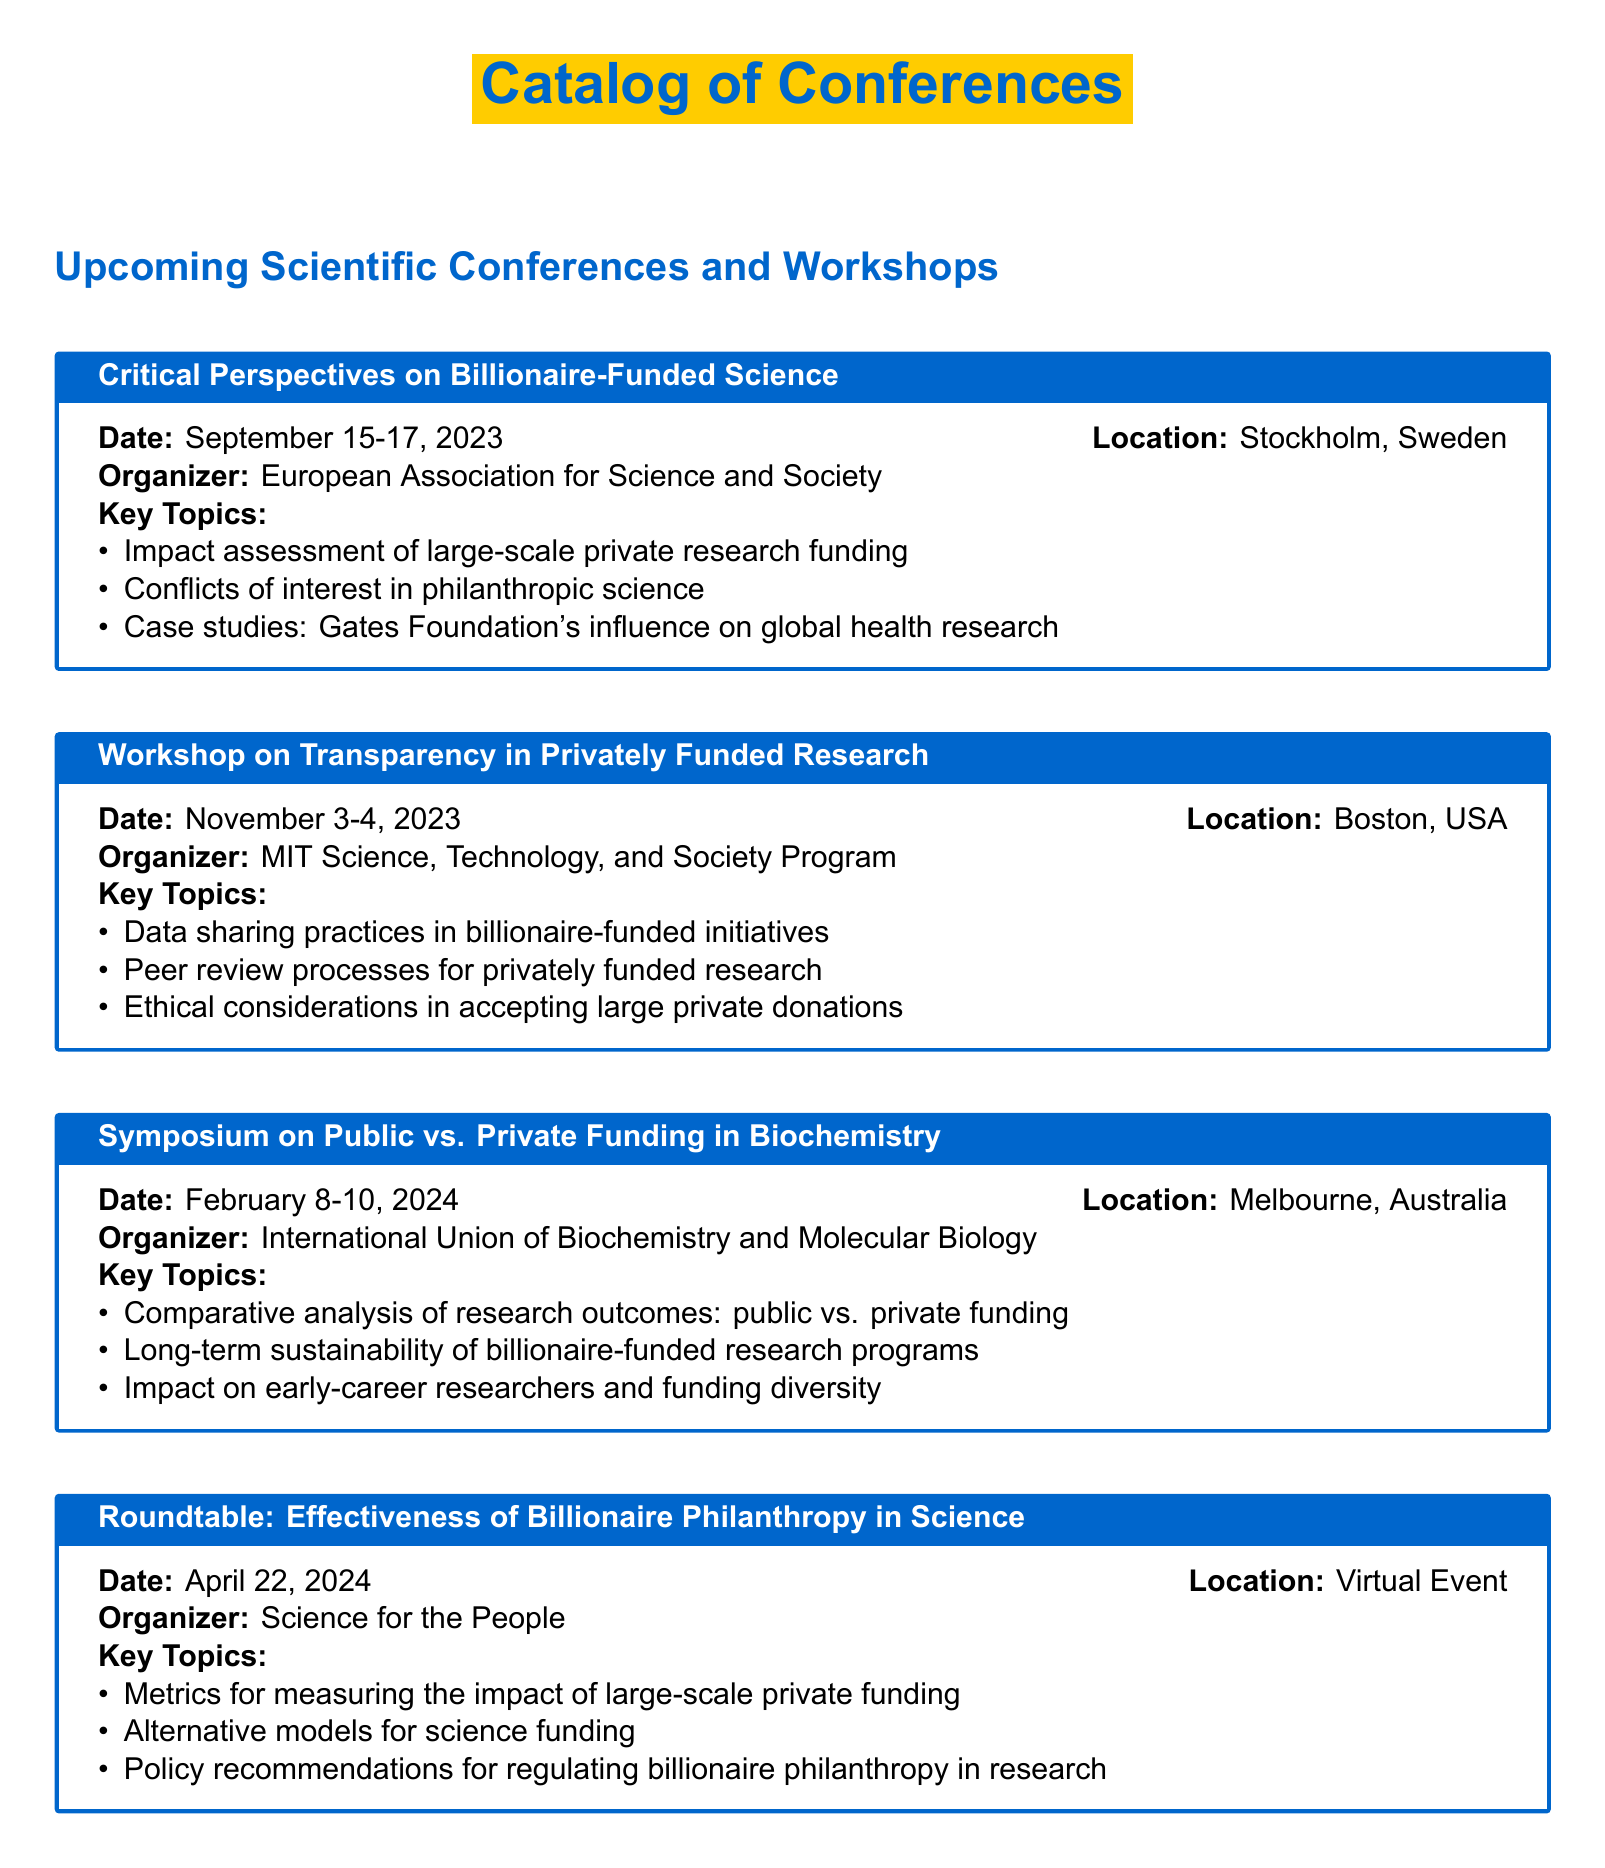What is the date of the Critical Perspectives on Billionaire-Funded Science? The date is provided in the event section of the document under the title, listing it as September 15-17, 2023.
Answer: September 15-17, 2023 Who is organizing the Workshop on Transparency in Privately Funded Research? The organizer is mentioned directly after the event title, listed as MIT Science, Technology, and Society Program.
Answer: MIT Science, Technology, and Society Program What location is hosting the Symposium on Public vs. Private Funding in Biochemistry? The location is stated in the event details, specifically as Melbourne, Australia.
Answer: Melbourne, Australia What are the key topics discussed in the Roundtable: Effectiveness of Billionaire Philanthropy in Science? Key topics are listed in bullet points beneath the event title, outlining specific subjects such as metrics for measuring impact.
Answer: Metrics for measuring the impact of large-scale private funding How many workshops are mentioned in the document? The total number of workshops is counted from the list of events, which includes the Workshop on Transparency in Privately Funded Research alone.
Answer: 1 What is the main focus of the Critical Perspectives on Billionaire-Funded Science? The focus is explicitly outlined in the key topics section of the event, indicating a view on the impact of private research funding.
Answer: Impact assessment of large-scale private research funding What type of event is scheduled for April 22, 2024? The document states that the event for this date is a virtual roundtable, categorized as such in the title.
Answer: Virtual Event Which conference discusses the influence of the Gates Foundation? The specific conference is mentioned in the key topics of the Critical Perspectives on Billionaire-Funded Science.
Answer: Critical Perspectives on Billionaire-Funded Science 